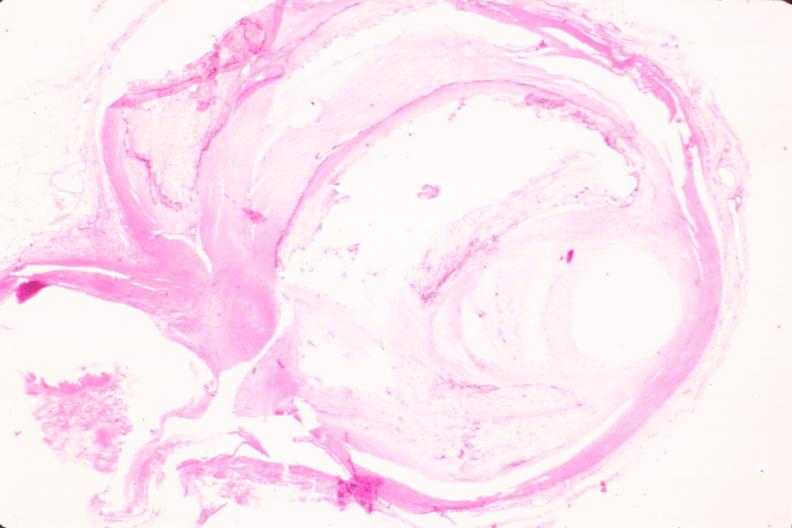s vasculature present?
Answer the question using a single word or phrase. Yes 